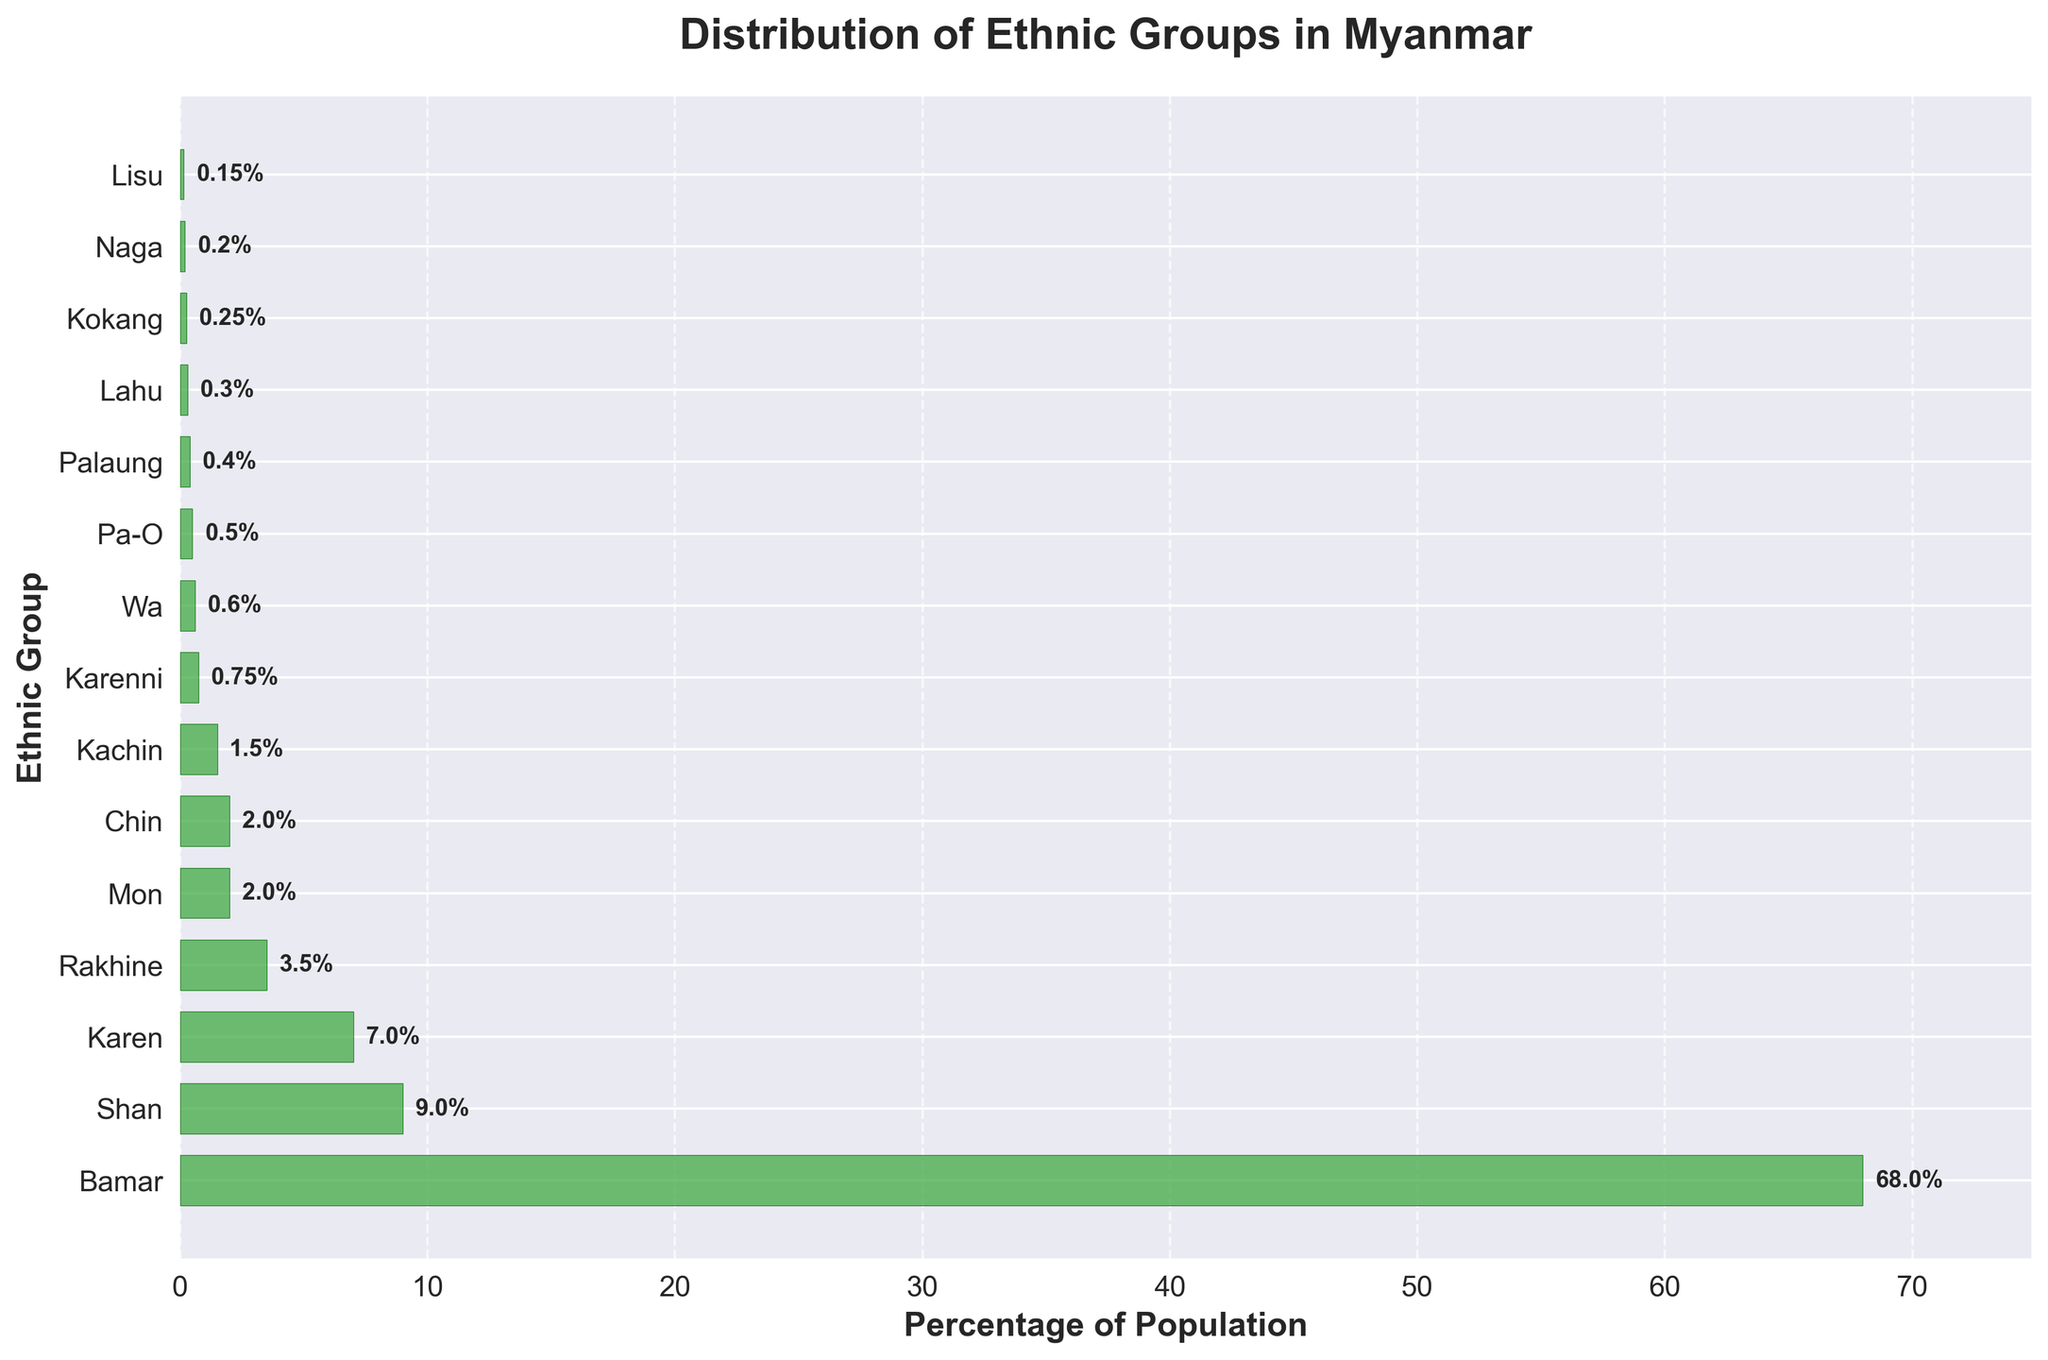How many ethnic groups are represented in the bar plot? Count the number of bars in the plot. There are 15 bars, each representing a different ethnic group.
Answer: 15 What percentage of the population is represented by the Mon ethnic group? Look at the bar corresponding to Mon. The label shows a percentage of 2%.
Answer: 2% Which ethnic group has the highest percentage of the population? Identify the longest bar in the plot. The Bamar ethnic group has the longest bar with 68%.
Answer: Bamar How much larger is the percentage of the Shan group compared to the Rakhine group? Subtract the percentage of Rakhine (3.5%) from the percentage of Shan (9%). 9% - 3.5% = 5.5%.
Answer: 5.5% What is the combined percentage of Karen, Kachin, and Pa-O groups? Sum the percentages of Karen (7%), Kachin (1.5%), and Pa-O (0.5%). 7% + 1.5% + 0.5% = 9%.
Answer: 9% How does the percentage of Karenni compare to that of Wa? Compare the percentages of Karenni (0.75%) and Wa (0.6%). Karenni has a higher percentage.
Answer: Karenni has a higher percentage Which ethnic group represents 0.3% of the population? Find the bar labeled 0.3%. The label shows Lahu.
Answer: Lahu What is the average percentage for the Mon, Chin, and Karen groups? Sum the percentages: Mon (2%), Chin (2%), and Karen (7%). Divide by 3. (2% + 2% + 7%) / 3 = 3.67%.
Answer: 3.67% Do any ethnic groups have less than 1% of the population? If so, which ones? Identify bars with percentages less than 1%. These groups are Karenni (0.75%), Wa (0.6%), Pa-O (0.5%), Palaung (0.4%), Lahu (0.3%), Kokang (0.25%), Naga (0.2%), and Lisu (0.15%).
Answer: Karenni, Wa, Pa-O, Palaung, Lahu, Kokang, Naga, Lisu What is the percentage difference between the Bamar and the Shan ethnic groups? Subtract the percentage of Shan (9%) from the percentage of Bamar (68%). 68% - 9% = 59%.
Answer: 59% 